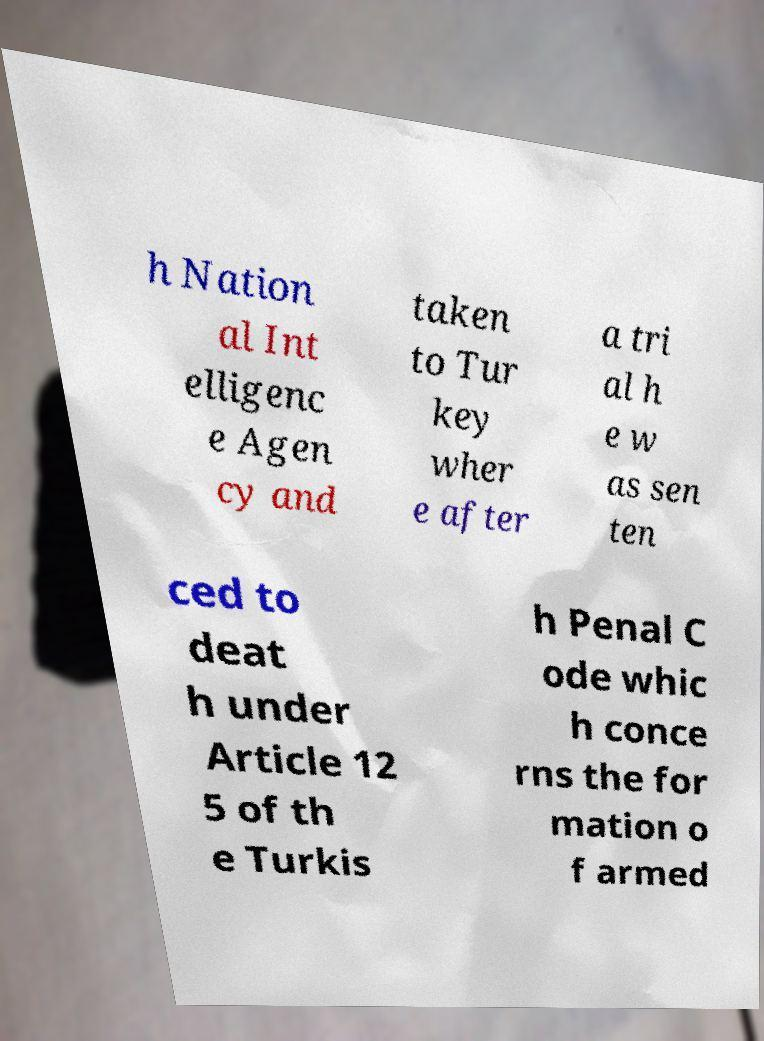Could you extract and type out the text from this image? h Nation al Int elligenc e Agen cy and taken to Tur key wher e after a tri al h e w as sen ten ced to deat h under Article 12 5 of th e Turkis h Penal C ode whic h conce rns the for mation o f armed 